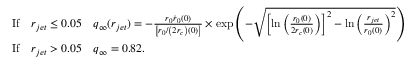Convert formula to latex. <formula><loc_0><loc_0><loc_500><loc_500>\begin{array} { r l } & { I f \quad r _ { j e t } \leq 0 . 0 5 \quad q _ { \infty } ( r _ { j e t } ) = - \frac { r _ { 0 } \dot { r } _ { 0 } ( 0 ) } { \left [ r _ { 0 } / \left ( 2 r _ { c } \right ) ( 0 ) \right ] } \times \exp \left ( - \sqrt { \left [ \ln \left ( \frac { r _ { 0 } ( 0 ) } { 2 r _ { c } ( 0 ) } \right ) \right ] ^ { 2 } - \ln \left ( \frac { r _ { j e t } } { r _ { 0 } ( 0 ) } \right ) ^ { 2 } } \right ) \, } \\ & { I f \quad r _ { j e t } > 0 . 0 5 \quad q _ { \infty } = 0 . 8 2 . } \end{array}</formula> 